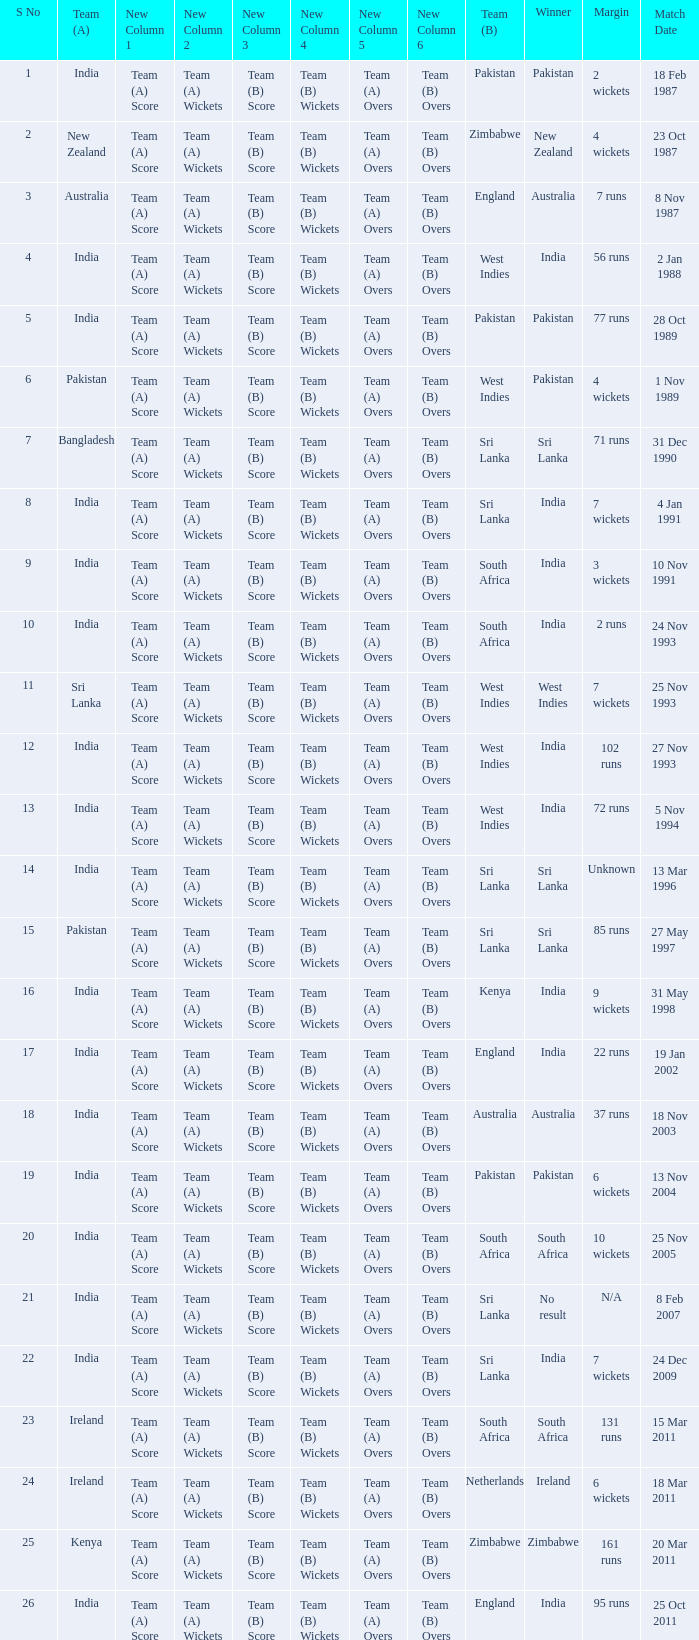Who won the match when the margin was 131 runs? South Africa. 